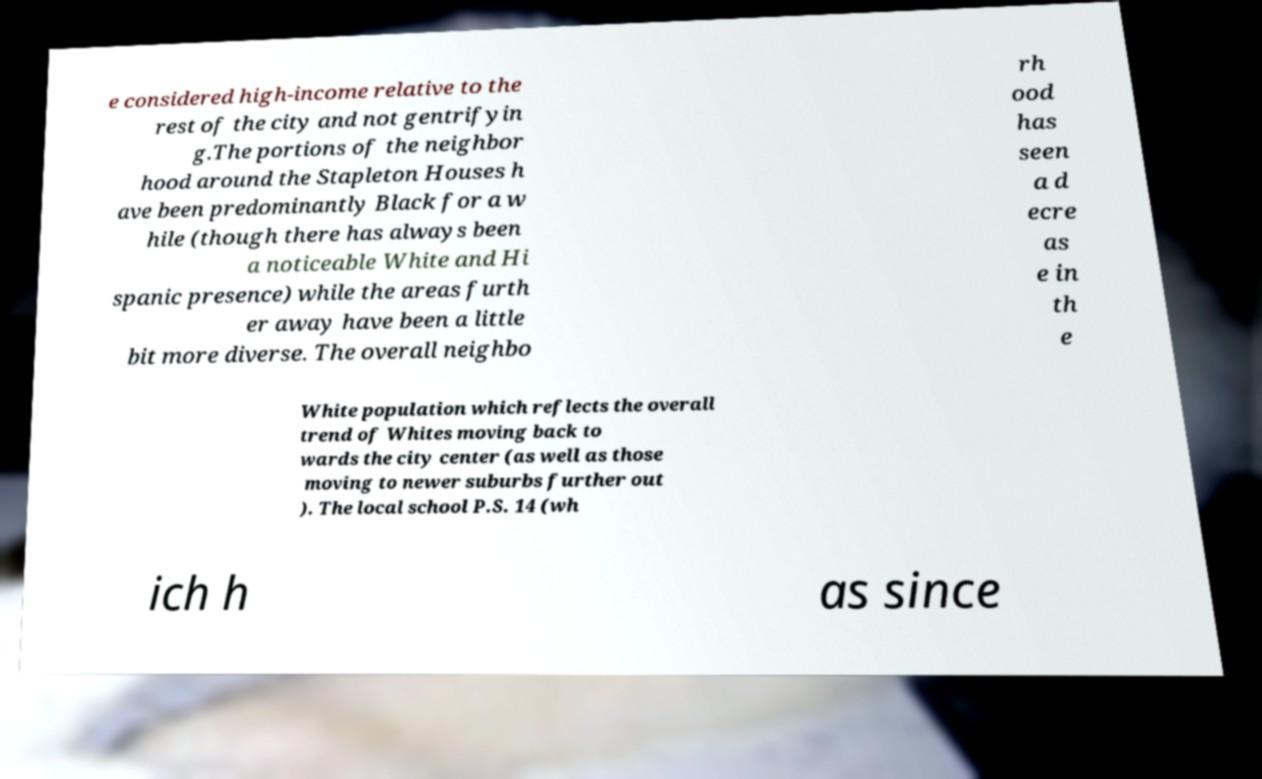There's text embedded in this image that I need extracted. Can you transcribe it verbatim? e considered high-income relative to the rest of the city and not gentrifyin g.The portions of the neighbor hood around the Stapleton Houses h ave been predominantly Black for a w hile (though there has always been a noticeable White and Hi spanic presence) while the areas furth er away have been a little bit more diverse. The overall neighbo rh ood has seen a d ecre as e in th e White population which reflects the overall trend of Whites moving back to wards the city center (as well as those moving to newer suburbs further out ). The local school P.S. 14 (wh ich h as since 